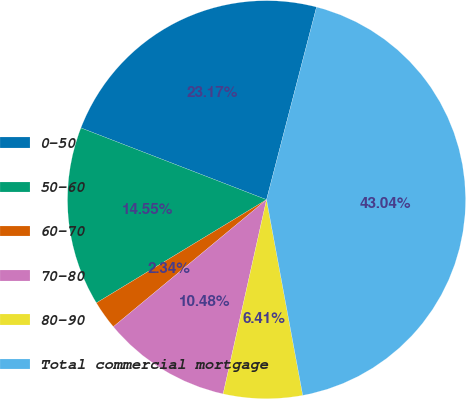<chart> <loc_0><loc_0><loc_500><loc_500><pie_chart><fcel>0-50<fcel>50-60<fcel>60-70<fcel>70-80<fcel>80-90<fcel>Total commercial mortgage<nl><fcel>23.17%<fcel>14.55%<fcel>2.34%<fcel>10.48%<fcel>6.41%<fcel>43.04%<nl></chart> 